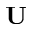Convert formula to latex. <formula><loc_0><loc_0><loc_500><loc_500>U</formula> 